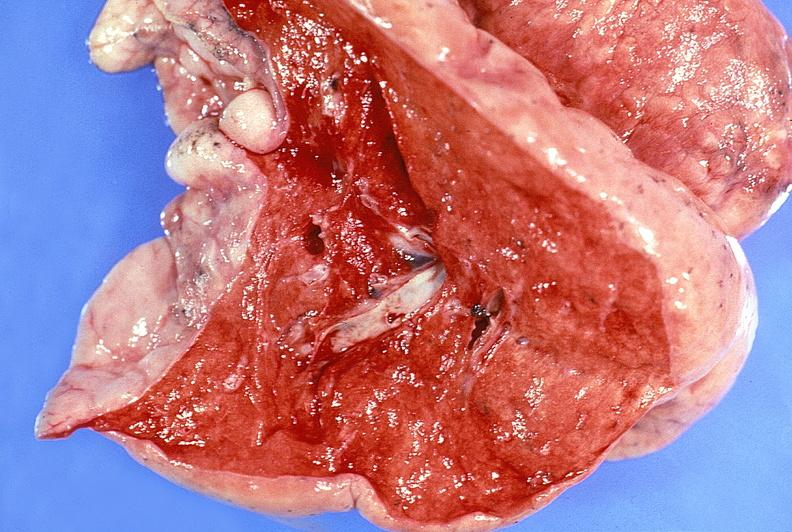s respiratory present?
Answer the question using a single word or phrase. Yes 